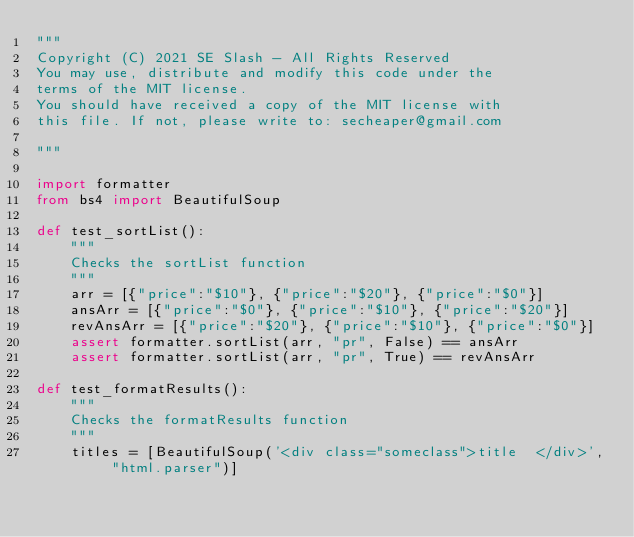<code> <loc_0><loc_0><loc_500><loc_500><_Python_>"""
Copyright (C) 2021 SE Slash - All Rights Reserved
You may use, distribute and modify this code under the
terms of the MIT license.
You should have received a copy of the MIT license with
this file. If not, please write to: secheaper@gmail.com

"""

import formatter
from bs4 import BeautifulSoup

def test_sortList():
    """
    Checks the sortList function
    """
    arr = [{"price":"$10"}, {"price":"$20"}, {"price":"$0"}]
    ansArr = [{"price":"$0"}, {"price":"$10"}, {"price":"$20"}]
    revAnsArr = [{"price":"$20"}, {"price":"$10"}, {"price":"$0"}]
    assert formatter.sortList(arr, "pr", False) == ansArr
    assert formatter.sortList(arr, "pr", True) == revAnsArr

def test_formatResults():
    """
    Checks the formatResults function
    """
    titles = [BeautifulSoup('<div class="someclass">title  </div>', "html.parser")]</code> 